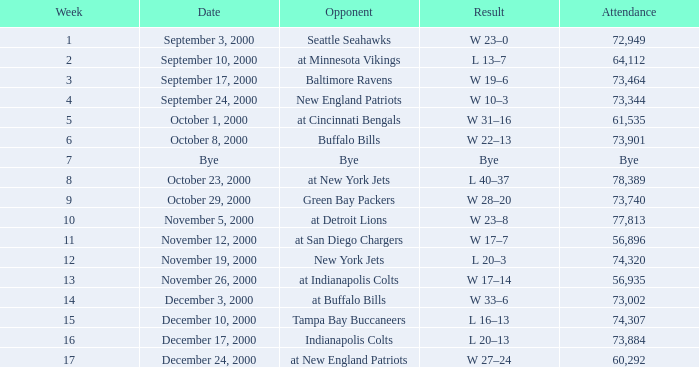What was the outcome of the game that had 72,949 spectators present? W 23–0. 